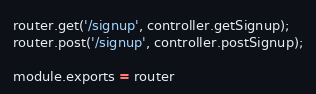Convert code to text. <code><loc_0><loc_0><loc_500><loc_500><_JavaScript_>router.get('/signup', controller.getSignup);
router.post('/signup', controller.postSignup);

module.exports = router</code> 